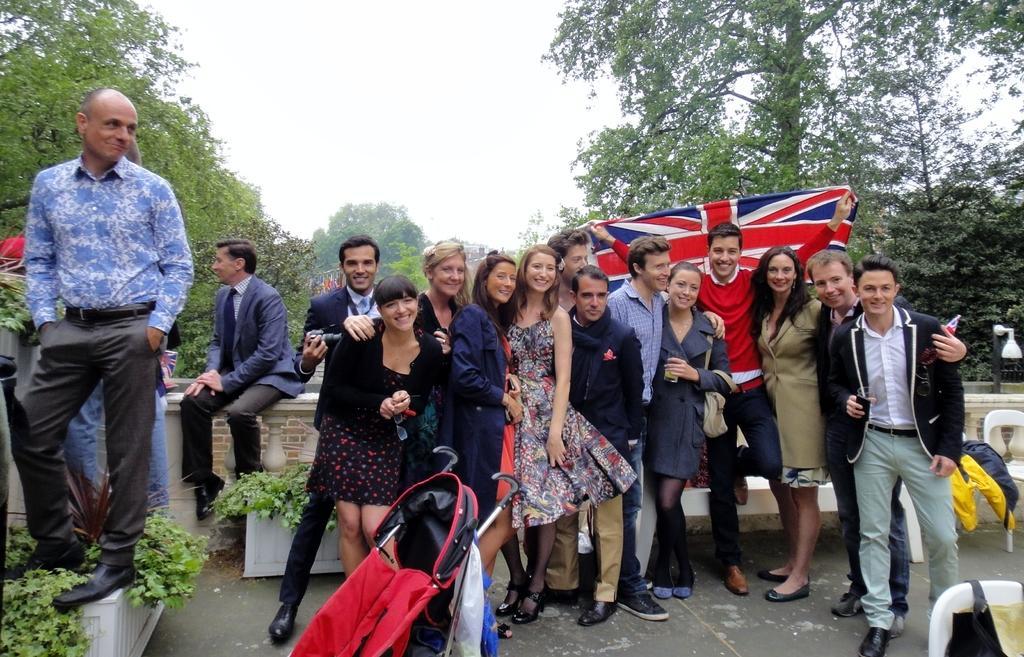Describe this image in one or two sentences. This image is clicked outside. There are trees in the middle. There is sky at the top. There are so many persons standing in the middle. One of them is holding a flag. 